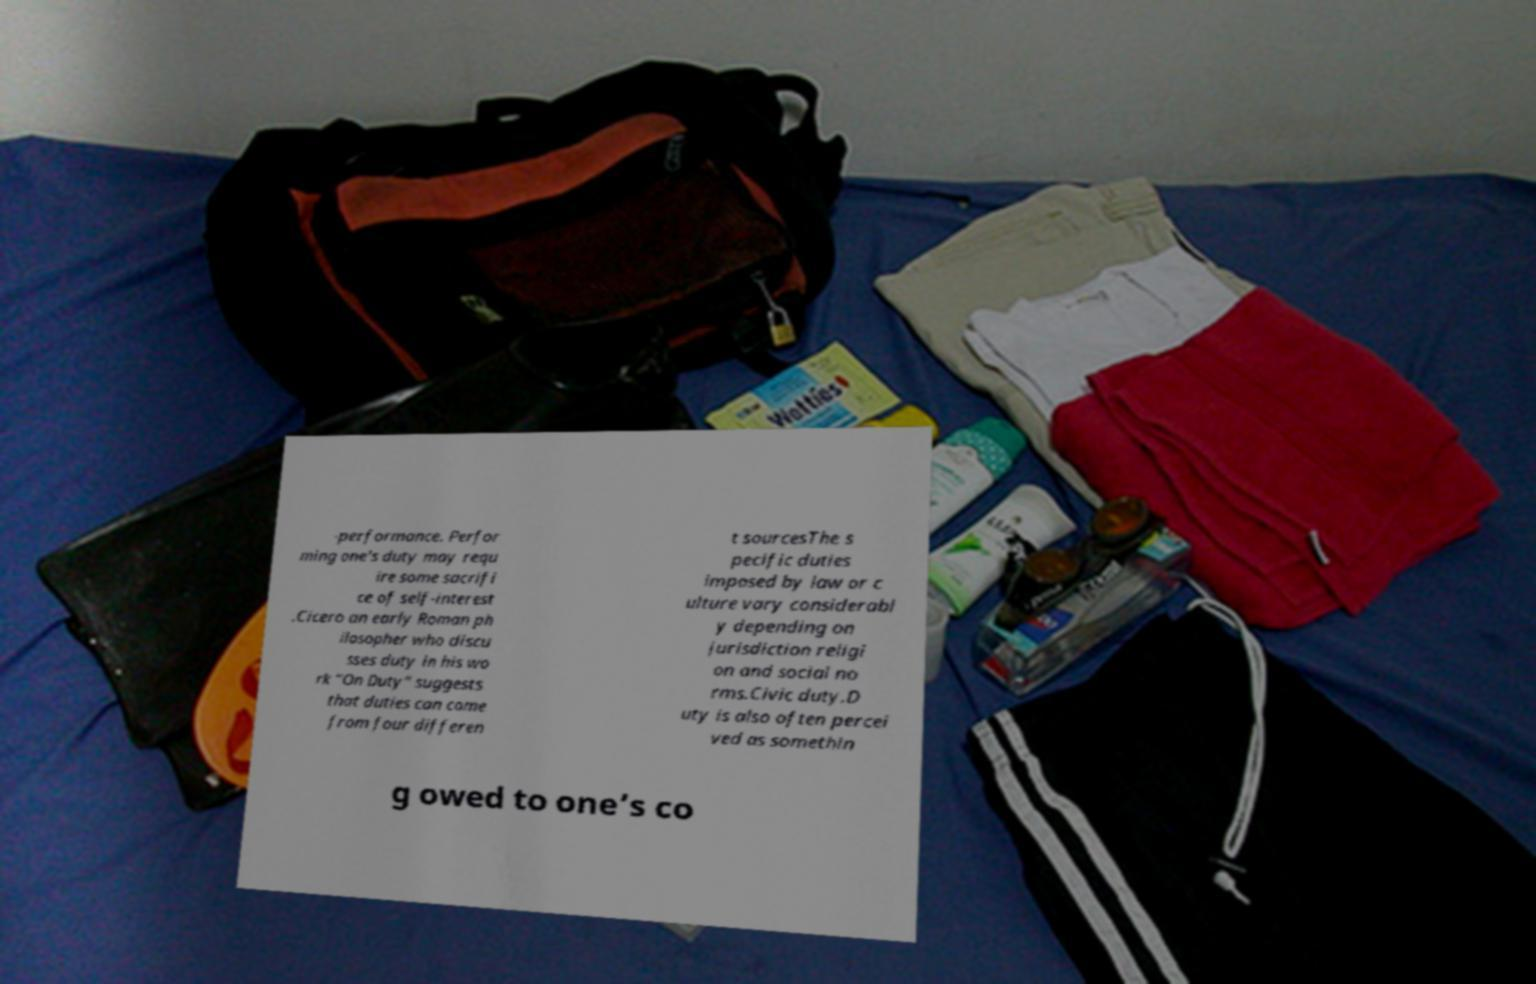Could you assist in decoding the text presented in this image and type it out clearly? -performance. Perfor ming one's duty may requ ire some sacrifi ce of self-interest .Cicero an early Roman ph ilosopher who discu sses duty in his wo rk “On Duty" suggests that duties can come from four differen t sourcesThe s pecific duties imposed by law or c ulture vary considerabl y depending on jurisdiction religi on and social no rms.Civic duty.D uty is also often percei ved as somethin g owed to one’s co 